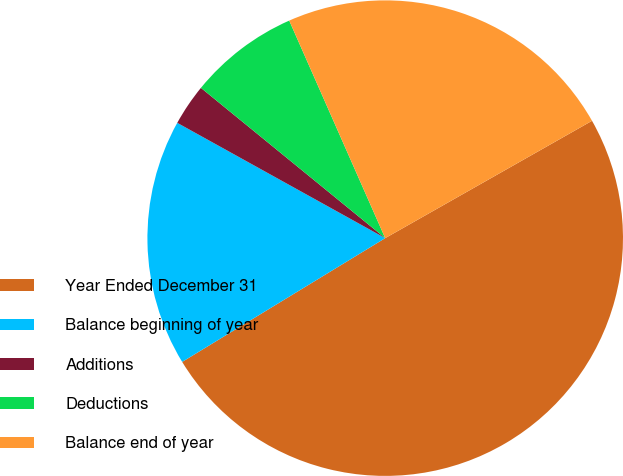<chart> <loc_0><loc_0><loc_500><loc_500><pie_chart><fcel>Year Ended December 31<fcel>Balance beginning of year<fcel>Additions<fcel>Deductions<fcel>Balance end of year<nl><fcel>49.5%<fcel>16.77%<fcel>2.83%<fcel>7.5%<fcel>23.4%<nl></chart> 